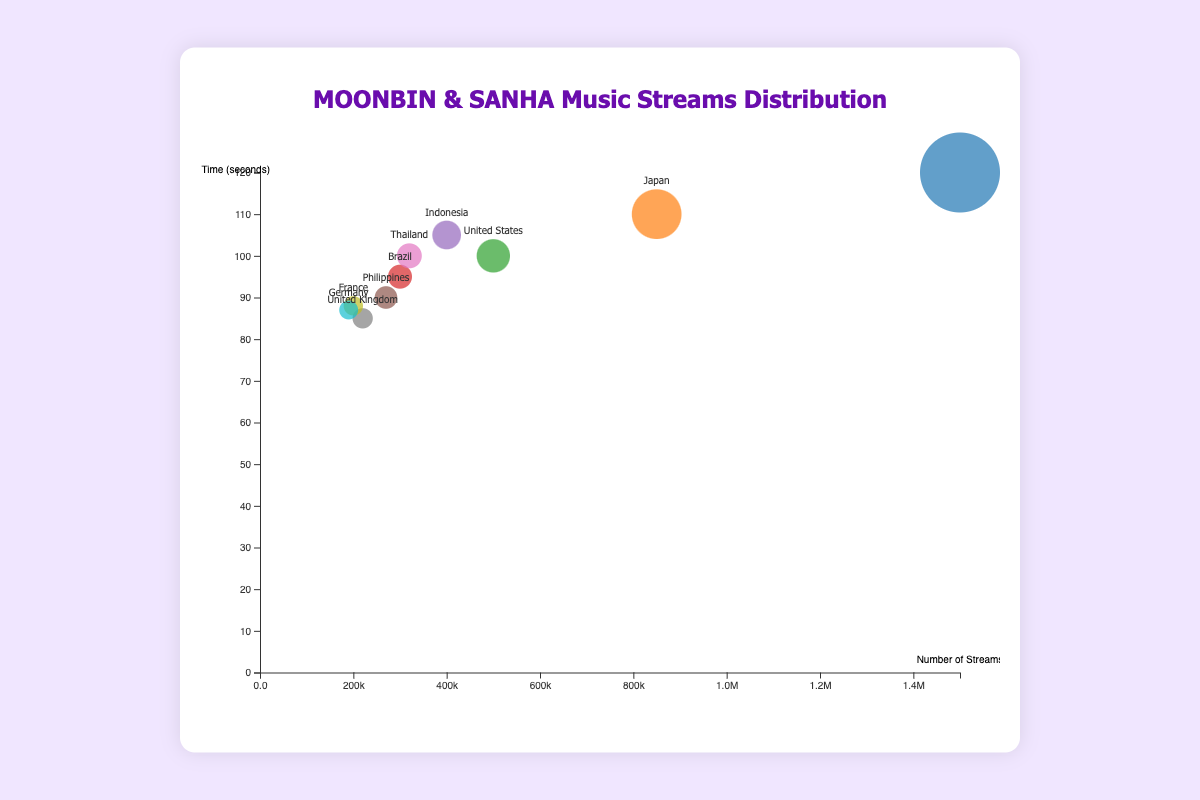How many countries are represented in the chart? By counting all the distinct data points (bubbles) in the chart, we can determine the number of countries. The chart shows points for South Korea, Japan, the United States, Brazil, Indonesia, the Philippines, Thailand, the United Kingdom, France, and Germany.
Answer: 10 Which country has the highest number of streams, and how many? By examining the x-axis, the largest bubble along this axis represents the country with the highest streams, which is South Korea with 1,500,000 streams.
Answer: South Korea, 1,500,000 Which country has the lowest average listening time? Checking the y-axis, the bubble closest to the bottom represents the country with the lowest average listening time. The United Kingdom has the lowest average listening time with 85 seconds.
Answer: United Kingdom, 85 What is the size of the bubble representing Japan, and what does it indicate? The size of each bubble is proportional to the number of streams, with Japan's bubble being one of the larger ones, indicating a high number of streams. Japan has 850,000 streams.
Answer: Large, indicating 850,000 streams Compare the average listening times between the United States and Indonesia. Which is longer? By locating both the United States and Indonesia on the y-axis, we see that Indonesia has an average listening time of 105 seconds, while the United States has 100 seconds. Therefore, Indonesia has a longer average listening time.
Answer: Indonesia, 105 seconds Which country has the closest number of streams to 300,000, and what is the precise value? Looking at the x-axis, the bubble representing Brazil is the closest to 300,000 streams, with an exact value of 300,000 streams.
Answer: Brazil, 300,000 What is the combined number of streams for the Philippines and Thailand? Checking the x-axis, the Philippines has 270,000 streams, and Thailand has 320,000. Adding these together gives 270,000 + 320,000 = 590,000 streams in total.
Answer: 590,000 Identify the country with about 87 average listening seconds and specify the exact country names. Observing the y-axis, both Germany (87 seconds) and France (88 seconds) have their average listening times close to 87 seconds.
Answer: Germany, France What are the average listening times for the countries with the two smallest bubble sizes? The two smallest bubbles represent the UK and Germany with respective average listening times of 85 seconds and 87 seconds.
Answer: 85 seconds (United Kingdom), 87 seconds (Germany) Which country has the second highest average listening time, and what is that time? By checking the y-axis, after South Korea (120 seconds), Japan has the next highest average listening time of 110 seconds.
Answer: Japan, 110 